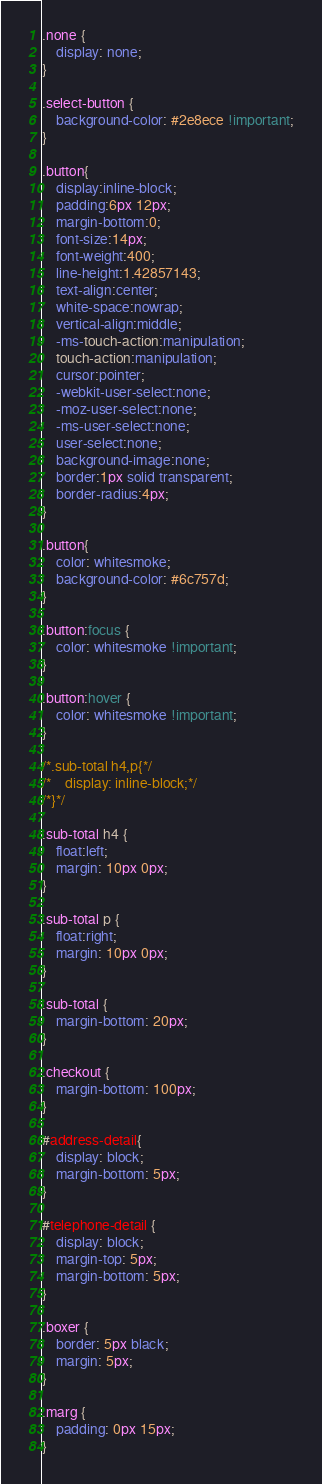<code> <loc_0><loc_0><loc_500><loc_500><_CSS_>.none {
    display: none;
}

.select-button {
    background-color: #2e8ece !important;
}

.button{
    display:inline-block;
    padding:6px 12px;
    margin-bottom:0;
    font-size:14px;
    font-weight:400;
    line-height:1.42857143;
    text-align:center;
    white-space:nowrap;
    vertical-align:middle;
    -ms-touch-action:manipulation;
    touch-action:manipulation;
    cursor:pointer;
    -webkit-user-select:none;
    -moz-user-select:none;
    -ms-user-select:none;
    user-select:none;
    background-image:none;
    border:1px solid transparent;
    border-radius:4px;
}

.button{
    color: whitesmoke;
    background-color: #6c757d;
}

.button:focus {
    color: whitesmoke !important;
}

.button:hover {
    color: whitesmoke !important;
}

/*.sub-total h4,p{*/
/*    display: inline-block;*/
/*}*/

.sub-total h4 {
    float:left;
    margin: 10px 0px;
}

.sub-total p {
    float:right;
    margin: 10px 0px;
}

.sub-total {
	margin-bottom: 20px;
}

.checkout {
    margin-bottom: 100px;
}

#address-detail{
	display: block;
	margin-bottom: 5px;
}

#telephone-detail {
	display: block;
	margin-top: 5px;
	margin-bottom: 5px;
}

.boxer {
	border: 5px black;
	margin: 5px;
}

.marg {
	padding: 0px 15px;
}

</code> 